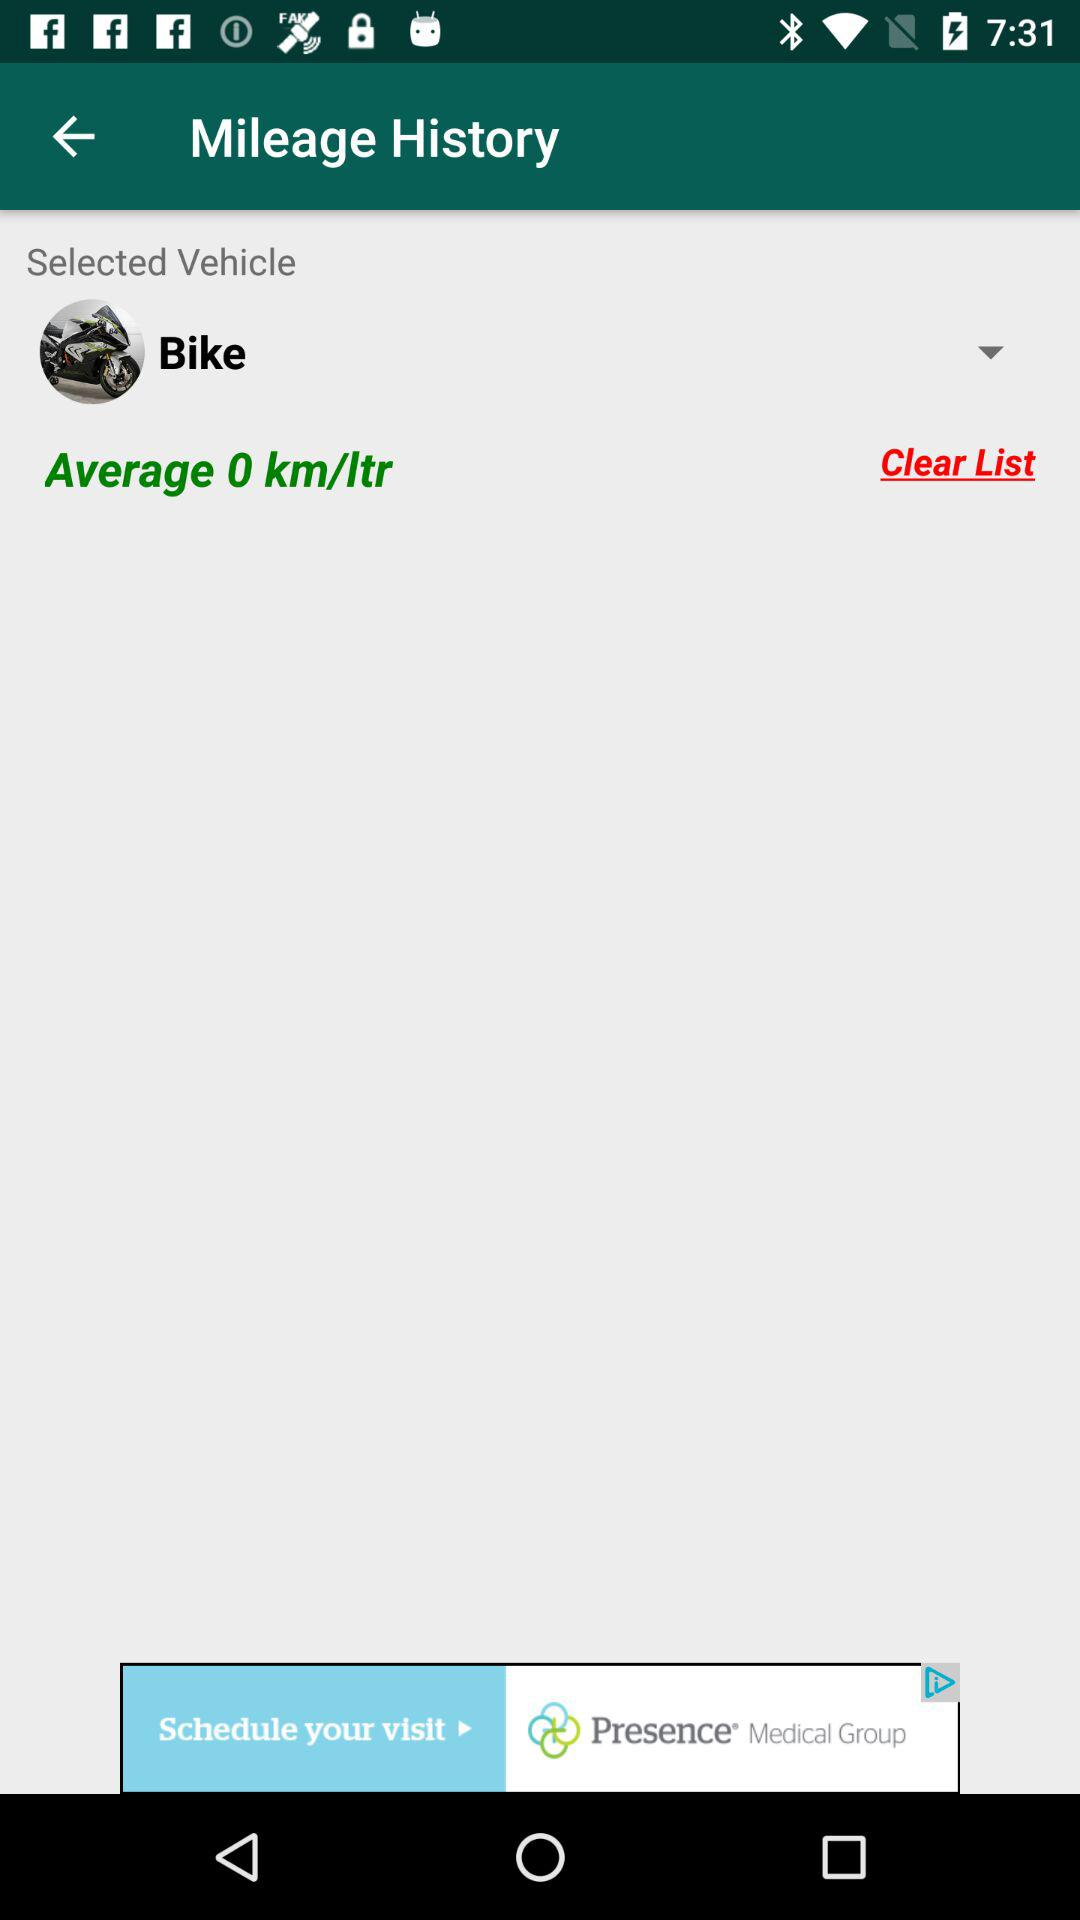How many kilometers per liter does this vehicle get?
Answer the question using a single word or phrase. 0 km/ltr 